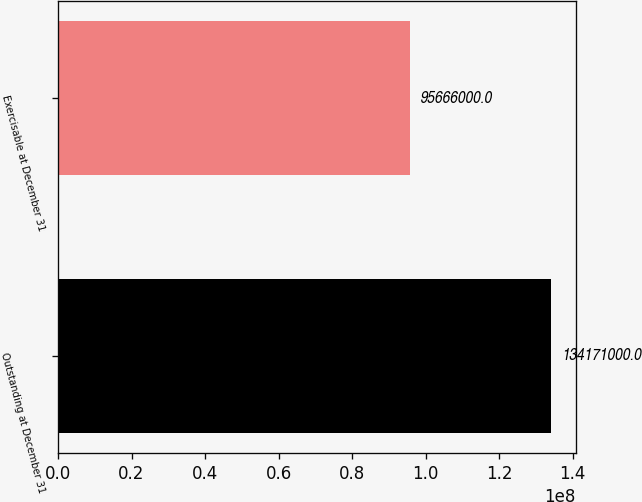<chart> <loc_0><loc_0><loc_500><loc_500><bar_chart><fcel>Outstanding at December 31<fcel>Exercisable at December 31<nl><fcel>1.34171e+08<fcel>9.5666e+07<nl></chart> 